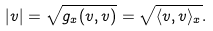<formula> <loc_0><loc_0><loc_500><loc_500>| v | = \sqrt { g _ { x } ( v , v ) } = \sqrt { \langle v , v \rangle _ { x } } .</formula> 